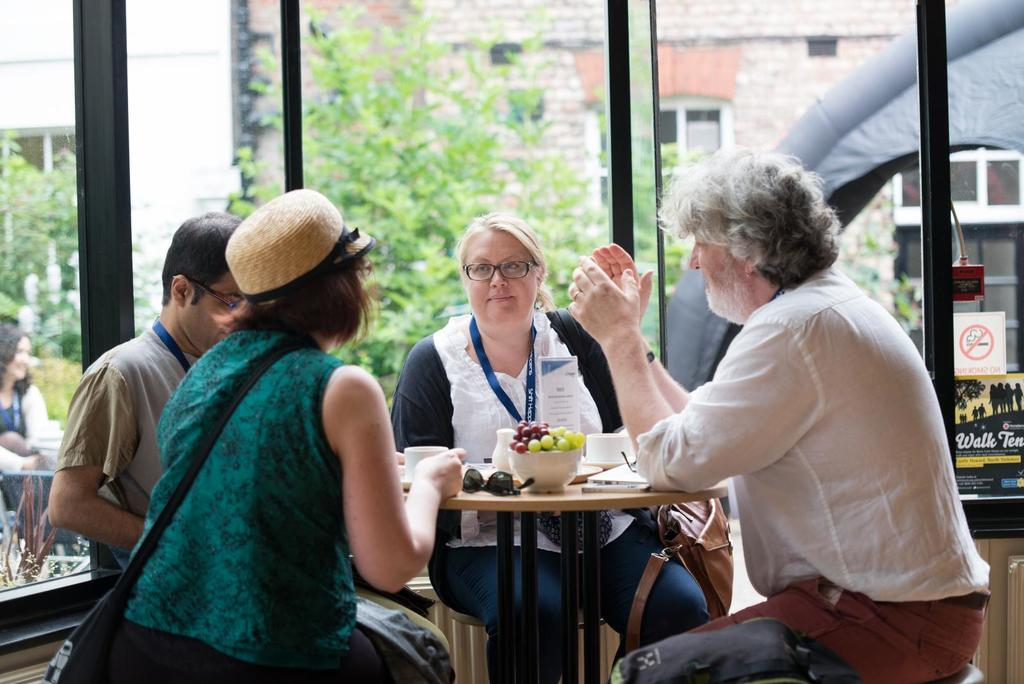What are the people in the image doing? There is a group of people sitting together in the image. What can be seen on the table in the image? There are fruits in a bowl and a cup on the table in the image. What is visible in the background of the image? There are trees and a building in the background of the image. What day of the week is it in the image? There is no information about the day of the week in the image. --- Facts: 1. There is a person in the image. 2. The person is wearing a hat. 3. The person is holding a book. 4. There is a table in the image. 5. There is a chair in the image. Absurd Topics: elephant, piano, ocean Conversation: Who or what is in the image? There is a person in the image. What is the person wearing? The person is wearing a hat. What is the person holding? The person is holding a book. What furniture is in the image? There is a table and a chair in the image. Reasoning: Let's think step by step in order to produce the conversation. We start by identifying the main subject in the image, which is the person. Then, we describe specific details about the person, such as the hat and the book they are holding. Next, we observe the furniture present in the image, which includes a table and a chair. Each question is designed to elicit a specific detail about the image that is known from the provided facts. Absurd Question/Answer: Can you hear the elephant playing the piano in the image? There is no elephant, piano, or ocean present in the image. 